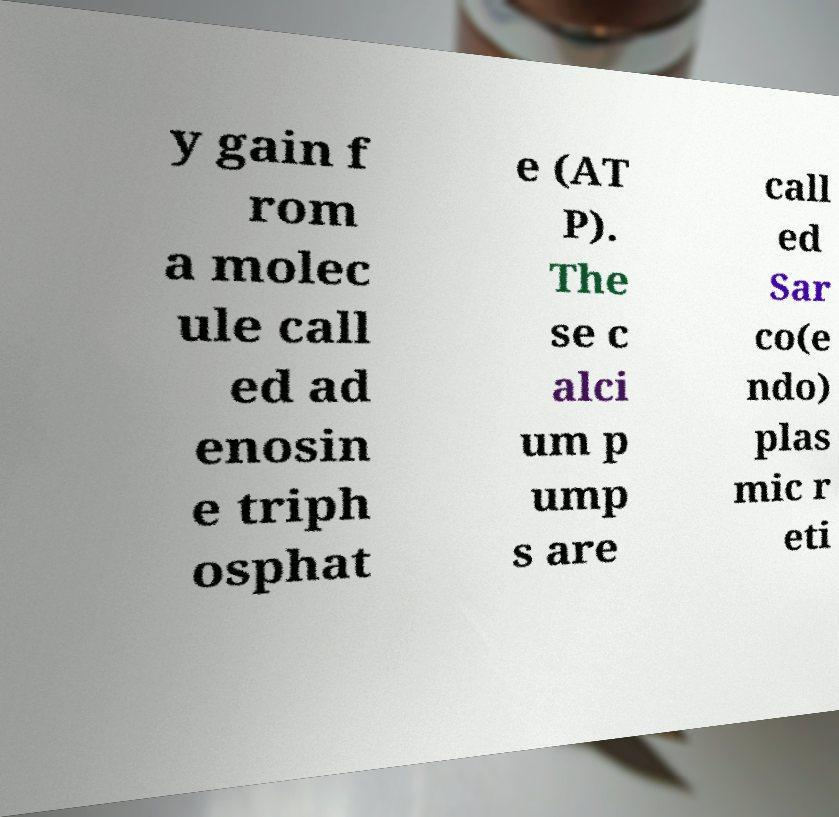I need the written content from this picture converted into text. Can you do that? y gain f rom a molec ule call ed ad enosin e triph osphat e (AT P). The se c alci um p ump s are call ed Sar co(e ndo) plas mic r eti 